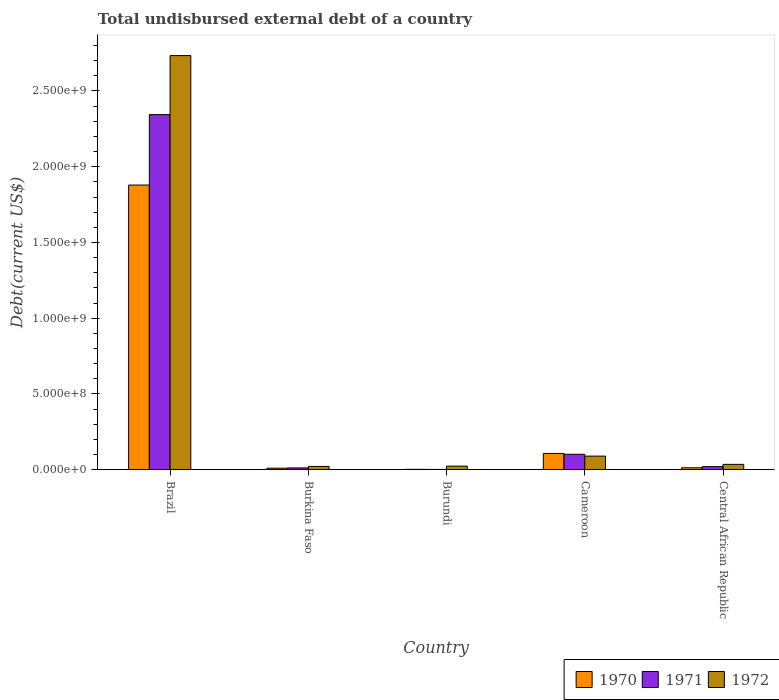How many different coloured bars are there?
Offer a very short reply. 3. How many groups of bars are there?
Ensure brevity in your answer.  5. Are the number of bars per tick equal to the number of legend labels?
Your answer should be very brief. Yes. How many bars are there on the 4th tick from the right?
Offer a terse response. 3. What is the label of the 5th group of bars from the left?
Provide a succinct answer. Central African Republic. In how many cases, is the number of bars for a given country not equal to the number of legend labels?
Your response must be concise. 0. What is the total undisbursed external debt in 1972 in Burkina Faso?
Ensure brevity in your answer.  2.16e+07. Across all countries, what is the maximum total undisbursed external debt in 1970?
Your answer should be very brief. 1.88e+09. Across all countries, what is the minimum total undisbursed external debt in 1970?
Ensure brevity in your answer.  2.42e+06. In which country was the total undisbursed external debt in 1971 maximum?
Give a very brief answer. Brazil. In which country was the total undisbursed external debt in 1970 minimum?
Give a very brief answer. Burundi. What is the total total undisbursed external debt in 1970 in the graph?
Offer a very short reply. 2.01e+09. What is the difference between the total undisbursed external debt in 1972 in Burkina Faso and that in Cameroon?
Your response must be concise. -6.80e+07. What is the difference between the total undisbursed external debt in 1972 in Brazil and the total undisbursed external debt in 1971 in Cameroon?
Give a very brief answer. 2.63e+09. What is the average total undisbursed external debt in 1971 per country?
Keep it short and to the point. 4.96e+08. What is the difference between the total undisbursed external debt of/in 1971 and total undisbursed external debt of/in 1972 in Cameroon?
Your response must be concise. 1.21e+07. What is the ratio of the total undisbursed external debt in 1971 in Burkina Faso to that in Central African Republic?
Offer a terse response. 0.57. What is the difference between the highest and the second highest total undisbursed external debt in 1971?
Make the answer very short. 2.32e+09. What is the difference between the highest and the lowest total undisbursed external debt in 1971?
Provide a short and direct response. 2.34e+09. Is it the case that in every country, the sum of the total undisbursed external debt in 1970 and total undisbursed external debt in 1972 is greater than the total undisbursed external debt in 1971?
Keep it short and to the point. Yes. Are all the bars in the graph horizontal?
Keep it short and to the point. No. Does the graph contain grids?
Provide a short and direct response. No. What is the title of the graph?
Offer a very short reply. Total undisbursed external debt of a country. What is the label or title of the Y-axis?
Offer a very short reply. Debt(current US$). What is the Debt(current US$) of 1970 in Brazil?
Offer a very short reply. 1.88e+09. What is the Debt(current US$) in 1971 in Brazil?
Make the answer very short. 2.34e+09. What is the Debt(current US$) of 1972 in Brazil?
Offer a terse response. 2.73e+09. What is the Debt(current US$) of 1970 in Burkina Faso?
Make the answer very short. 1.01e+07. What is the Debt(current US$) in 1971 in Burkina Faso?
Your response must be concise. 1.16e+07. What is the Debt(current US$) in 1972 in Burkina Faso?
Offer a terse response. 2.16e+07. What is the Debt(current US$) in 1970 in Burundi?
Your answer should be very brief. 2.42e+06. What is the Debt(current US$) in 1971 in Burundi?
Your response must be concise. 1.93e+06. What is the Debt(current US$) in 1972 in Burundi?
Provide a short and direct response. 2.37e+07. What is the Debt(current US$) of 1970 in Cameroon?
Provide a short and direct response. 1.07e+08. What is the Debt(current US$) in 1971 in Cameroon?
Your response must be concise. 1.02e+08. What is the Debt(current US$) in 1972 in Cameroon?
Your answer should be compact. 8.96e+07. What is the Debt(current US$) of 1970 in Central African Republic?
Keep it short and to the point. 1.26e+07. What is the Debt(current US$) in 1971 in Central African Republic?
Provide a succinct answer. 2.03e+07. What is the Debt(current US$) in 1972 in Central African Republic?
Make the answer very short. 3.52e+07. Across all countries, what is the maximum Debt(current US$) of 1970?
Your answer should be very brief. 1.88e+09. Across all countries, what is the maximum Debt(current US$) of 1971?
Give a very brief answer. 2.34e+09. Across all countries, what is the maximum Debt(current US$) of 1972?
Offer a very short reply. 2.73e+09. Across all countries, what is the minimum Debt(current US$) of 1970?
Your answer should be compact. 2.42e+06. Across all countries, what is the minimum Debt(current US$) in 1971?
Keep it short and to the point. 1.93e+06. Across all countries, what is the minimum Debt(current US$) in 1972?
Make the answer very short. 2.16e+07. What is the total Debt(current US$) of 1970 in the graph?
Provide a short and direct response. 2.01e+09. What is the total Debt(current US$) in 1971 in the graph?
Offer a terse response. 2.48e+09. What is the total Debt(current US$) of 1972 in the graph?
Ensure brevity in your answer.  2.90e+09. What is the difference between the Debt(current US$) in 1970 in Brazil and that in Burkina Faso?
Provide a short and direct response. 1.87e+09. What is the difference between the Debt(current US$) of 1971 in Brazil and that in Burkina Faso?
Your response must be concise. 2.33e+09. What is the difference between the Debt(current US$) in 1972 in Brazil and that in Burkina Faso?
Keep it short and to the point. 2.71e+09. What is the difference between the Debt(current US$) of 1970 in Brazil and that in Burundi?
Your answer should be very brief. 1.88e+09. What is the difference between the Debt(current US$) of 1971 in Brazil and that in Burundi?
Provide a short and direct response. 2.34e+09. What is the difference between the Debt(current US$) of 1972 in Brazil and that in Burundi?
Offer a very short reply. 2.71e+09. What is the difference between the Debt(current US$) in 1970 in Brazil and that in Cameroon?
Offer a very short reply. 1.77e+09. What is the difference between the Debt(current US$) of 1971 in Brazil and that in Cameroon?
Provide a succinct answer. 2.24e+09. What is the difference between the Debt(current US$) of 1972 in Brazil and that in Cameroon?
Ensure brevity in your answer.  2.64e+09. What is the difference between the Debt(current US$) of 1970 in Brazil and that in Central African Republic?
Offer a very short reply. 1.87e+09. What is the difference between the Debt(current US$) of 1971 in Brazil and that in Central African Republic?
Offer a very short reply. 2.32e+09. What is the difference between the Debt(current US$) in 1972 in Brazil and that in Central African Republic?
Keep it short and to the point. 2.70e+09. What is the difference between the Debt(current US$) of 1970 in Burkina Faso and that in Burundi?
Keep it short and to the point. 7.64e+06. What is the difference between the Debt(current US$) of 1971 in Burkina Faso and that in Burundi?
Offer a terse response. 9.71e+06. What is the difference between the Debt(current US$) in 1972 in Burkina Faso and that in Burundi?
Offer a terse response. -2.08e+06. What is the difference between the Debt(current US$) of 1970 in Burkina Faso and that in Cameroon?
Ensure brevity in your answer.  -9.72e+07. What is the difference between the Debt(current US$) of 1971 in Burkina Faso and that in Cameroon?
Provide a succinct answer. -9.00e+07. What is the difference between the Debt(current US$) in 1972 in Burkina Faso and that in Cameroon?
Offer a terse response. -6.80e+07. What is the difference between the Debt(current US$) of 1970 in Burkina Faso and that in Central African Republic?
Your response must be concise. -2.50e+06. What is the difference between the Debt(current US$) of 1971 in Burkina Faso and that in Central African Republic?
Offer a terse response. -8.66e+06. What is the difference between the Debt(current US$) of 1972 in Burkina Faso and that in Central African Republic?
Your response must be concise. -1.36e+07. What is the difference between the Debt(current US$) of 1970 in Burundi and that in Cameroon?
Your answer should be compact. -1.05e+08. What is the difference between the Debt(current US$) of 1971 in Burundi and that in Cameroon?
Your answer should be very brief. -9.97e+07. What is the difference between the Debt(current US$) in 1972 in Burundi and that in Cameroon?
Make the answer very short. -6.59e+07. What is the difference between the Debt(current US$) of 1970 in Burundi and that in Central African Republic?
Provide a short and direct response. -1.01e+07. What is the difference between the Debt(current US$) of 1971 in Burundi and that in Central African Republic?
Your answer should be very brief. -1.84e+07. What is the difference between the Debt(current US$) of 1972 in Burundi and that in Central African Republic?
Your answer should be compact. -1.16e+07. What is the difference between the Debt(current US$) of 1970 in Cameroon and that in Central African Republic?
Your answer should be very brief. 9.47e+07. What is the difference between the Debt(current US$) of 1971 in Cameroon and that in Central African Republic?
Give a very brief answer. 8.14e+07. What is the difference between the Debt(current US$) in 1972 in Cameroon and that in Central African Republic?
Your answer should be very brief. 5.44e+07. What is the difference between the Debt(current US$) in 1970 in Brazil and the Debt(current US$) in 1971 in Burkina Faso?
Provide a short and direct response. 1.87e+09. What is the difference between the Debt(current US$) in 1970 in Brazil and the Debt(current US$) in 1972 in Burkina Faso?
Ensure brevity in your answer.  1.86e+09. What is the difference between the Debt(current US$) in 1971 in Brazil and the Debt(current US$) in 1972 in Burkina Faso?
Make the answer very short. 2.32e+09. What is the difference between the Debt(current US$) in 1970 in Brazil and the Debt(current US$) in 1971 in Burundi?
Offer a terse response. 1.88e+09. What is the difference between the Debt(current US$) of 1970 in Brazil and the Debt(current US$) of 1972 in Burundi?
Offer a very short reply. 1.86e+09. What is the difference between the Debt(current US$) in 1971 in Brazil and the Debt(current US$) in 1972 in Burundi?
Give a very brief answer. 2.32e+09. What is the difference between the Debt(current US$) of 1970 in Brazil and the Debt(current US$) of 1971 in Cameroon?
Provide a succinct answer. 1.78e+09. What is the difference between the Debt(current US$) in 1970 in Brazil and the Debt(current US$) in 1972 in Cameroon?
Your answer should be compact. 1.79e+09. What is the difference between the Debt(current US$) of 1971 in Brazil and the Debt(current US$) of 1972 in Cameroon?
Your answer should be compact. 2.25e+09. What is the difference between the Debt(current US$) of 1970 in Brazil and the Debt(current US$) of 1971 in Central African Republic?
Provide a short and direct response. 1.86e+09. What is the difference between the Debt(current US$) of 1970 in Brazil and the Debt(current US$) of 1972 in Central African Republic?
Keep it short and to the point. 1.84e+09. What is the difference between the Debt(current US$) in 1971 in Brazil and the Debt(current US$) in 1972 in Central African Republic?
Make the answer very short. 2.31e+09. What is the difference between the Debt(current US$) of 1970 in Burkina Faso and the Debt(current US$) of 1971 in Burundi?
Provide a short and direct response. 8.14e+06. What is the difference between the Debt(current US$) of 1970 in Burkina Faso and the Debt(current US$) of 1972 in Burundi?
Ensure brevity in your answer.  -1.36e+07. What is the difference between the Debt(current US$) in 1971 in Burkina Faso and the Debt(current US$) in 1972 in Burundi?
Your response must be concise. -1.20e+07. What is the difference between the Debt(current US$) of 1970 in Burkina Faso and the Debt(current US$) of 1971 in Cameroon?
Your answer should be compact. -9.16e+07. What is the difference between the Debt(current US$) in 1970 in Burkina Faso and the Debt(current US$) in 1972 in Cameroon?
Your answer should be very brief. -7.95e+07. What is the difference between the Debt(current US$) of 1971 in Burkina Faso and the Debt(current US$) of 1972 in Cameroon?
Keep it short and to the point. -7.80e+07. What is the difference between the Debt(current US$) in 1970 in Burkina Faso and the Debt(current US$) in 1971 in Central African Republic?
Ensure brevity in your answer.  -1.02e+07. What is the difference between the Debt(current US$) of 1970 in Burkina Faso and the Debt(current US$) of 1972 in Central African Republic?
Ensure brevity in your answer.  -2.52e+07. What is the difference between the Debt(current US$) of 1971 in Burkina Faso and the Debt(current US$) of 1972 in Central African Republic?
Offer a terse response. -2.36e+07. What is the difference between the Debt(current US$) of 1970 in Burundi and the Debt(current US$) of 1971 in Cameroon?
Make the answer very short. -9.92e+07. What is the difference between the Debt(current US$) of 1970 in Burundi and the Debt(current US$) of 1972 in Cameroon?
Offer a very short reply. -8.72e+07. What is the difference between the Debt(current US$) of 1971 in Burundi and the Debt(current US$) of 1972 in Cameroon?
Provide a succinct answer. -8.77e+07. What is the difference between the Debt(current US$) in 1970 in Burundi and the Debt(current US$) in 1971 in Central African Republic?
Give a very brief answer. -1.79e+07. What is the difference between the Debt(current US$) of 1970 in Burundi and the Debt(current US$) of 1972 in Central African Republic?
Give a very brief answer. -3.28e+07. What is the difference between the Debt(current US$) in 1971 in Burundi and the Debt(current US$) in 1972 in Central African Republic?
Your response must be concise. -3.33e+07. What is the difference between the Debt(current US$) in 1970 in Cameroon and the Debt(current US$) in 1971 in Central African Republic?
Provide a succinct answer. 8.69e+07. What is the difference between the Debt(current US$) in 1970 in Cameroon and the Debt(current US$) in 1972 in Central African Republic?
Keep it short and to the point. 7.20e+07. What is the difference between the Debt(current US$) of 1971 in Cameroon and the Debt(current US$) of 1972 in Central African Republic?
Your response must be concise. 6.64e+07. What is the average Debt(current US$) of 1970 per country?
Offer a terse response. 4.02e+08. What is the average Debt(current US$) in 1971 per country?
Your answer should be compact. 4.96e+08. What is the average Debt(current US$) of 1972 per country?
Give a very brief answer. 5.81e+08. What is the difference between the Debt(current US$) in 1970 and Debt(current US$) in 1971 in Brazil?
Ensure brevity in your answer.  -4.65e+08. What is the difference between the Debt(current US$) of 1970 and Debt(current US$) of 1972 in Brazil?
Keep it short and to the point. -8.55e+08. What is the difference between the Debt(current US$) of 1971 and Debt(current US$) of 1972 in Brazil?
Provide a short and direct response. -3.90e+08. What is the difference between the Debt(current US$) in 1970 and Debt(current US$) in 1971 in Burkina Faso?
Make the answer very short. -1.58e+06. What is the difference between the Debt(current US$) in 1970 and Debt(current US$) in 1972 in Burkina Faso?
Offer a very short reply. -1.15e+07. What is the difference between the Debt(current US$) of 1971 and Debt(current US$) of 1972 in Burkina Faso?
Provide a succinct answer. -9.93e+06. What is the difference between the Debt(current US$) of 1970 and Debt(current US$) of 1971 in Burundi?
Provide a succinct answer. 4.96e+05. What is the difference between the Debt(current US$) in 1970 and Debt(current US$) in 1972 in Burundi?
Keep it short and to the point. -2.12e+07. What is the difference between the Debt(current US$) in 1971 and Debt(current US$) in 1972 in Burundi?
Provide a short and direct response. -2.17e+07. What is the difference between the Debt(current US$) of 1970 and Debt(current US$) of 1971 in Cameroon?
Offer a very short reply. 5.58e+06. What is the difference between the Debt(current US$) in 1970 and Debt(current US$) in 1972 in Cameroon?
Provide a succinct answer. 1.77e+07. What is the difference between the Debt(current US$) in 1971 and Debt(current US$) in 1972 in Cameroon?
Give a very brief answer. 1.21e+07. What is the difference between the Debt(current US$) of 1970 and Debt(current US$) of 1971 in Central African Republic?
Your answer should be compact. -7.74e+06. What is the difference between the Debt(current US$) in 1970 and Debt(current US$) in 1972 in Central African Republic?
Provide a succinct answer. -2.27e+07. What is the difference between the Debt(current US$) of 1971 and Debt(current US$) of 1972 in Central African Republic?
Give a very brief answer. -1.49e+07. What is the ratio of the Debt(current US$) in 1970 in Brazil to that in Burkina Faso?
Ensure brevity in your answer.  186.68. What is the ratio of the Debt(current US$) of 1971 in Brazil to that in Burkina Faso?
Offer a terse response. 201.33. What is the ratio of the Debt(current US$) in 1972 in Brazil to that in Burkina Faso?
Provide a short and direct response. 126.69. What is the ratio of the Debt(current US$) of 1970 in Brazil to that in Burundi?
Your answer should be very brief. 774.83. What is the ratio of the Debt(current US$) of 1971 in Brazil to that in Burundi?
Ensure brevity in your answer.  1215.1. What is the ratio of the Debt(current US$) of 1972 in Brazil to that in Burundi?
Make the answer very short. 115.55. What is the ratio of the Debt(current US$) in 1970 in Brazil to that in Cameroon?
Your answer should be compact. 17.52. What is the ratio of the Debt(current US$) in 1971 in Brazil to that in Cameroon?
Make the answer very short. 23.06. What is the ratio of the Debt(current US$) of 1972 in Brazil to that in Cameroon?
Offer a very short reply. 30.51. What is the ratio of the Debt(current US$) in 1970 in Brazil to that in Central African Republic?
Your response must be concise. 149.58. What is the ratio of the Debt(current US$) in 1971 in Brazil to that in Central African Republic?
Offer a very short reply. 115.42. What is the ratio of the Debt(current US$) of 1972 in Brazil to that in Central African Republic?
Offer a terse response. 77.61. What is the ratio of the Debt(current US$) of 1970 in Burkina Faso to that in Burundi?
Provide a short and direct response. 4.15. What is the ratio of the Debt(current US$) of 1971 in Burkina Faso to that in Burundi?
Offer a very short reply. 6.04. What is the ratio of the Debt(current US$) in 1972 in Burkina Faso to that in Burundi?
Give a very brief answer. 0.91. What is the ratio of the Debt(current US$) of 1970 in Burkina Faso to that in Cameroon?
Provide a succinct answer. 0.09. What is the ratio of the Debt(current US$) of 1971 in Burkina Faso to that in Cameroon?
Ensure brevity in your answer.  0.11. What is the ratio of the Debt(current US$) in 1972 in Burkina Faso to that in Cameroon?
Ensure brevity in your answer.  0.24. What is the ratio of the Debt(current US$) of 1970 in Burkina Faso to that in Central African Republic?
Your answer should be very brief. 0.8. What is the ratio of the Debt(current US$) in 1971 in Burkina Faso to that in Central African Republic?
Provide a succinct answer. 0.57. What is the ratio of the Debt(current US$) of 1972 in Burkina Faso to that in Central African Republic?
Make the answer very short. 0.61. What is the ratio of the Debt(current US$) in 1970 in Burundi to that in Cameroon?
Ensure brevity in your answer.  0.02. What is the ratio of the Debt(current US$) of 1971 in Burundi to that in Cameroon?
Provide a short and direct response. 0.02. What is the ratio of the Debt(current US$) in 1972 in Burundi to that in Cameroon?
Ensure brevity in your answer.  0.26. What is the ratio of the Debt(current US$) in 1970 in Burundi to that in Central African Republic?
Offer a very short reply. 0.19. What is the ratio of the Debt(current US$) in 1971 in Burundi to that in Central African Republic?
Keep it short and to the point. 0.1. What is the ratio of the Debt(current US$) in 1972 in Burundi to that in Central African Republic?
Your response must be concise. 0.67. What is the ratio of the Debt(current US$) in 1970 in Cameroon to that in Central African Republic?
Your response must be concise. 8.54. What is the ratio of the Debt(current US$) in 1971 in Cameroon to that in Central African Republic?
Your response must be concise. 5.01. What is the ratio of the Debt(current US$) of 1972 in Cameroon to that in Central African Republic?
Offer a terse response. 2.54. What is the difference between the highest and the second highest Debt(current US$) of 1970?
Offer a terse response. 1.77e+09. What is the difference between the highest and the second highest Debt(current US$) in 1971?
Make the answer very short. 2.24e+09. What is the difference between the highest and the second highest Debt(current US$) of 1972?
Your answer should be compact. 2.64e+09. What is the difference between the highest and the lowest Debt(current US$) of 1970?
Provide a short and direct response. 1.88e+09. What is the difference between the highest and the lowest Debt(current US$) in 1971?
Keep it short and to the point. 2.34e+09. What is the difference between the highest and the lowest Debt(current US$) in 1972?
Keep it short and to the point. 2.71e+09. 